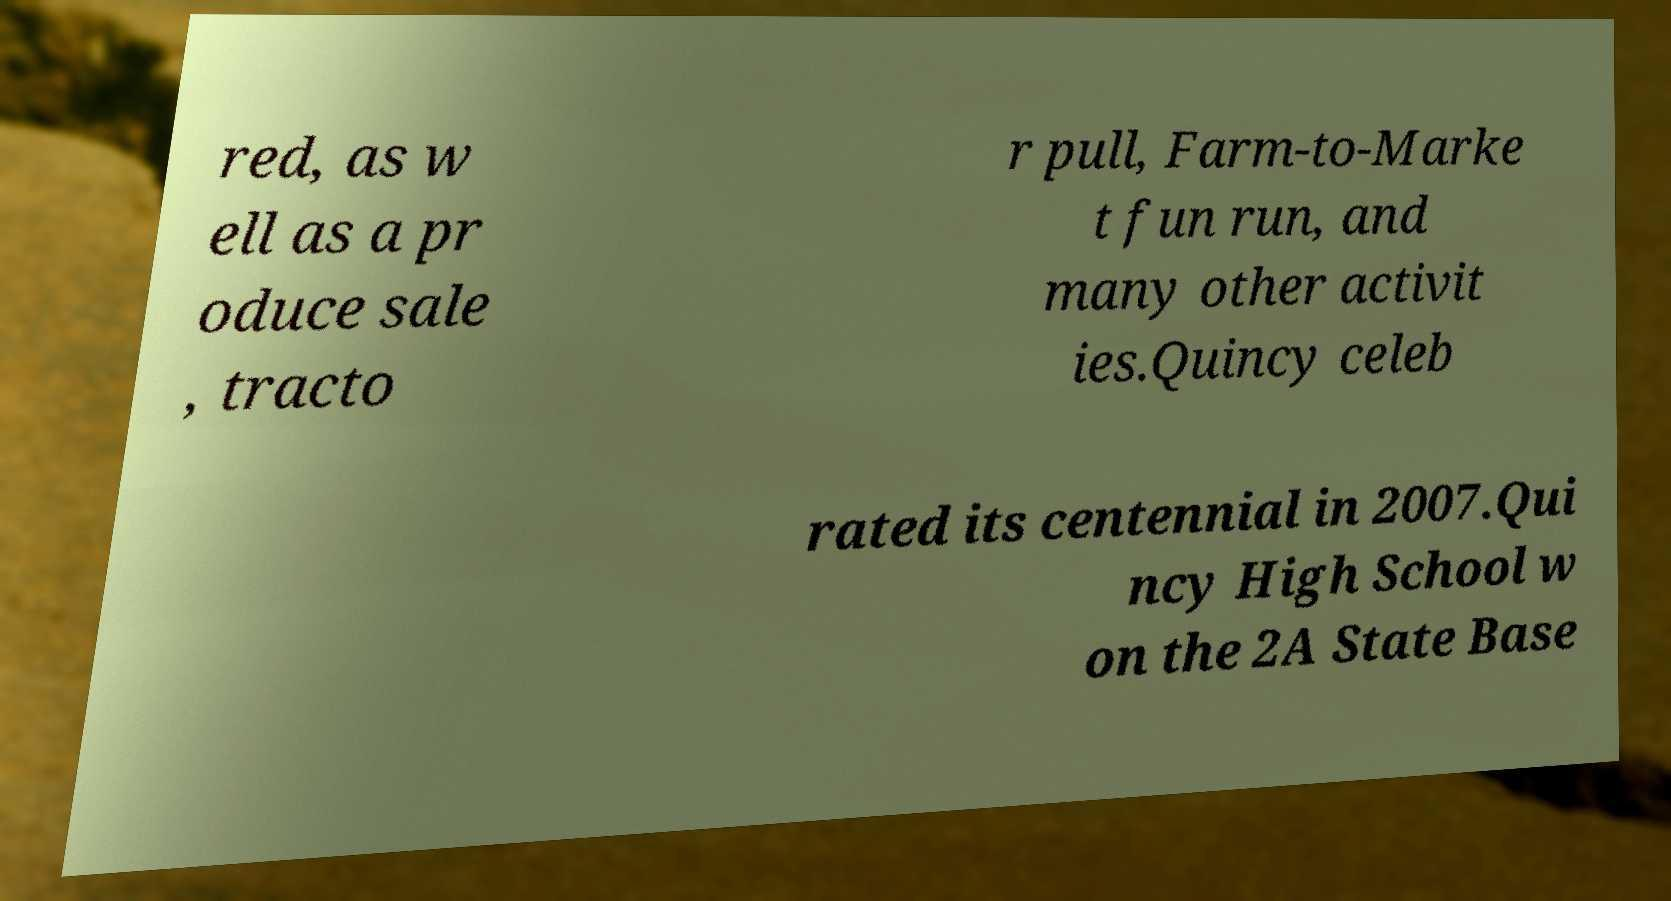I need the written content from this picture converted into text. Can you do that? red, as w ell as a pr oduce sale , tracto r pull, Farm-to-Marke t fun run, and many other activit ies.Quincy celeb rated its centennial in 2007.Qui ncy High School w on the 2A State Base 